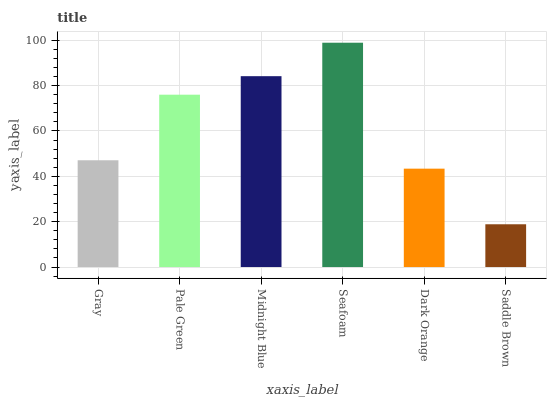Is Saddle Brown the minimum?
Answer yes or no. Yes. Is Seafoam the maximum?
Answer yes or no. Yes. Is Pale Green the minimum?
Answer yes or no. No. Is Pale Green the maximum?
Answer yes or no. No. Is Pale Green greater than Gray?
Answer yes or no. Yes. Is Gray less than Pale Green?
Answer yes or no. Yes. Is Gray greater than Pale Green?
Answer yes or no. No. Is Pale Green less than Gray?
Answer yes or no. No. Is Pale Green the high median?
Answer yes or no. Yes. Is Gray the low median?
Answer yes or no. Yes. Is Saddle Brown the high median?
Answer yes or no. No. Is Midnight Blue the low median?
Answer yes or no. No. 